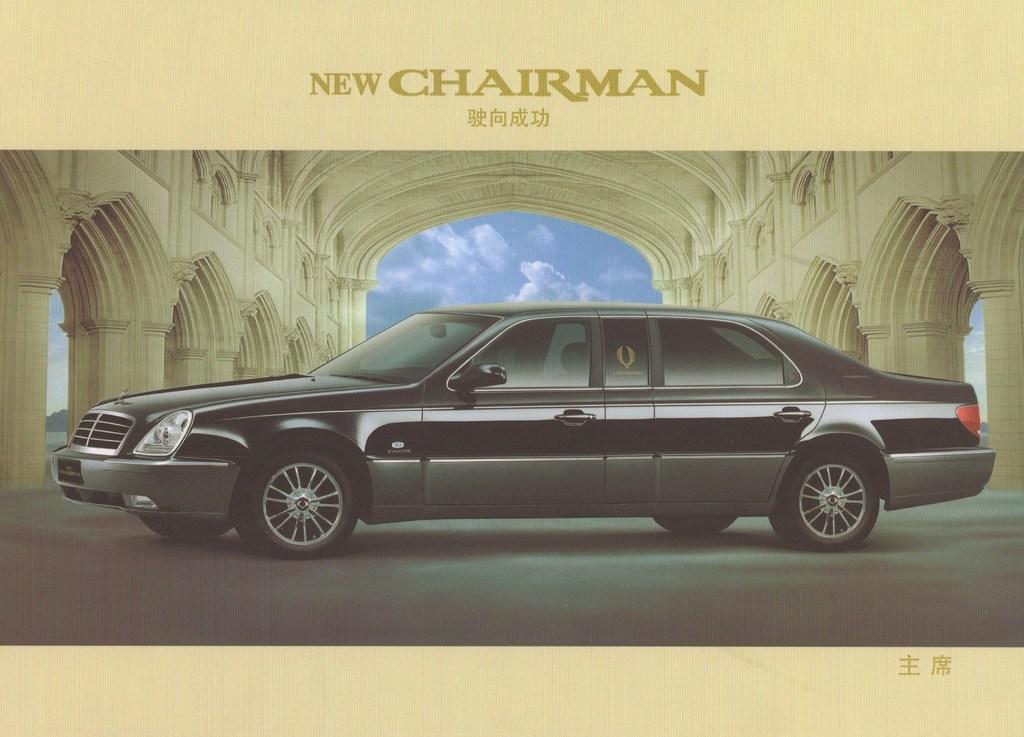How would you summarize this image in a sentence or two? In the picture we can see the art of a black color car, we can see the pillars, ceiling and the sky with clouds in the background. Here we can see the edited text at the top of the image. 